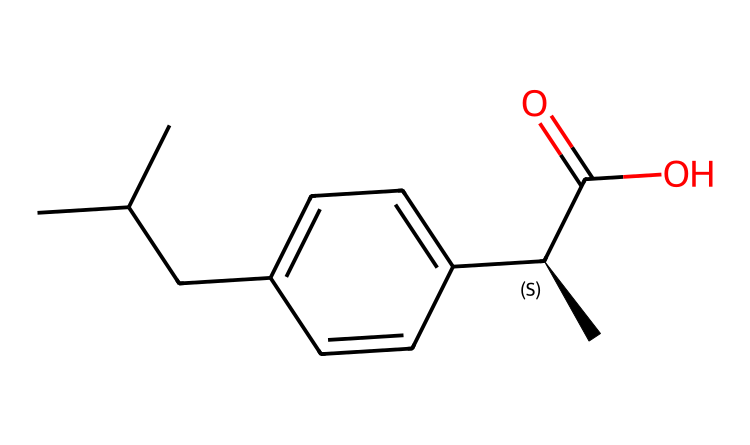How many chiral centers are present in ibuprofen? In the provided SMILES representation, the notation "[C@H]" indicates a chiral center which contains four different substituents. By analyzing the structure, we can see that there is only one chiral center.
Answer: one chiral center What is the functional group present in ibuprofen? The -C(=O)O part of the SMILES represents a carboxylic acid functional group, characterized by the carbon atom double-bonded to an oxygen atom and single-bonded to a hydroxyl group. This confirms the presence of a carboxylic acid in ibuprofen.
Answer: carboxylic acid How many carbon atoms are there in ibuprofen? By counting each carbon atom represented in the SMILES notation, we find a total of 13 carbon atoms. This includes both the side chains and the aromatic ring.
Answer: thirteen carbon atoms What is the molecular formula for ibuprofen based on the SMILES? By analyzing the SMILES, we can account for the various atoms present: 13 carbon (C), 18 hydrogen (H), and 2 oxygen (O) atoms. This leads to the molecular formula of C13H18O2.
Answer: C13H18O2 What type of stereoisomerism is exhibited by ibuprofen? Given the presence of a chiral center, ibuprofen exhibits stereoisomerism as a result of the different spatial arrangements of atoms at that center. This type of stereoisomerism is known as chiral or optical isomerism, as it forms enantiomers.
Answer: optical isomerism 